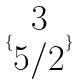<formula> <loc_0><loc_0><loc_500><loc_500>\{ \begin{matrix} 3 \\ 5 / 2 \end{matrix} \}</formula> 